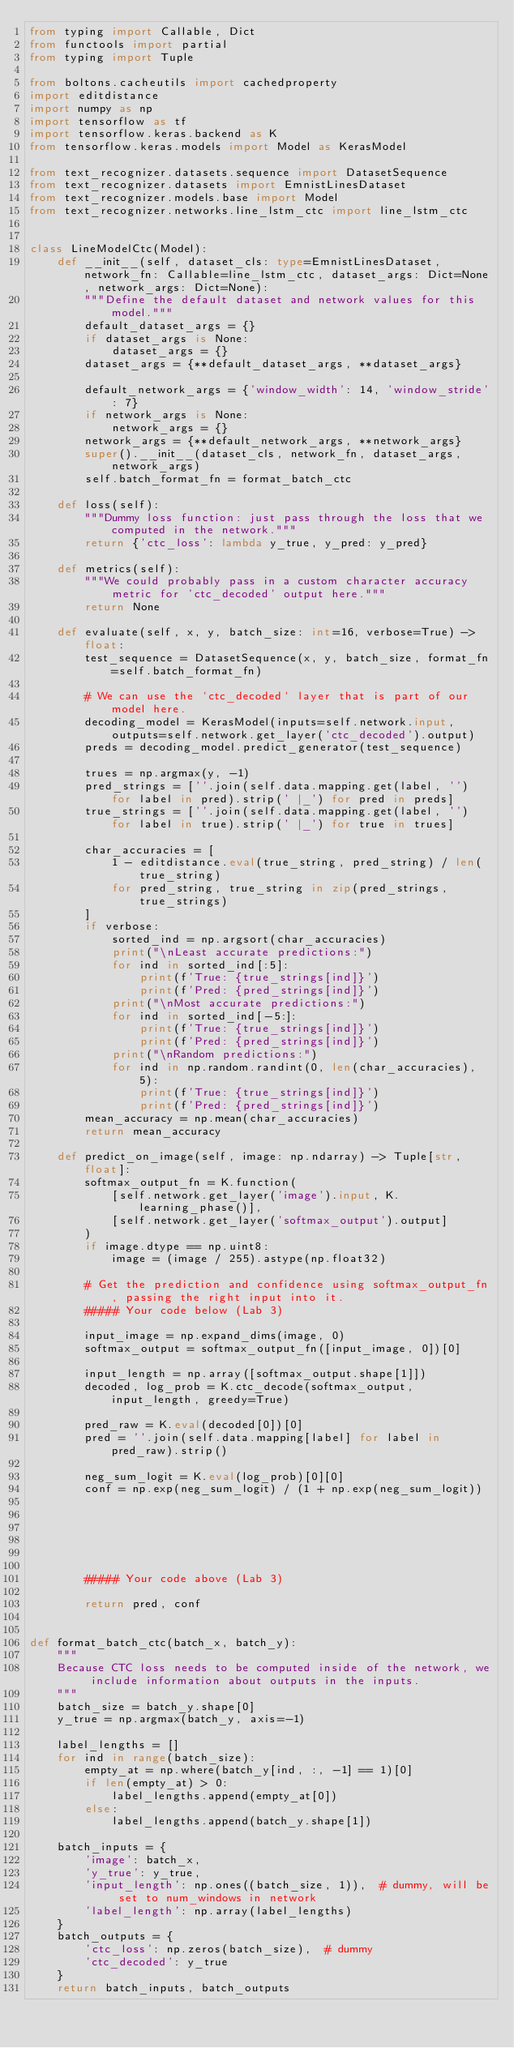<code> <loc_0><loc_0><loc_500><loc_500><_Python_>from typing import Callable, Dict
from functools import partial
from typing import Tuple

from boltons.cacheutils import cachedproperty
import editdistance
import numpy as np
import tensorflow as tf
import tensorflow.keras.backend as K
from tensorflow.keras.models import Model as KerasModel

from text_recognizer.datasets.sequence import DatasetSequence
from text_recognizer.datasets import EmnistLinesDataset
from text_recognizer.models.base import Model
from text_recognizer.networks.line_lstm_ctc import line_lstm_ctc


class LineModelCtc(Model):
    def __init__(self, dataset_cls: type=EmnistLinesDataset, network_fn: Callable=line_lstm_ctc, dataset_args: Dict=None, network_args: Dict=None):
        """Define the default dataset and network values for this model."""
        default_dataset_args = {}
        if dataset_args is None:
            dataset_args = {}
        dataset_args = {**default_dataset_args, **dataset_args}

        default_network_args = {'window_width': 14, 'window_stride': 7}
        if network_args is None:
            network_args = {}
        network_args = {**default_network_args, **network_args}
        super().__init__(dataset_cls, network_fn, dataset_args, network_args)
        self.batch_format_fn = format_batch_ctc

    def loss(self):
        """Dummy loss function: just pass through the loss that we computed in the network."""
        return {'ctc_loss': lambda y_true, y_pred: y_pred}

    def metrics(self):
        """We could probably pass in a custom character accuracy metric for 'ctc_decoded' output here."""
        return None

    def evaluate(self, x, y, batch_size: int=16, verbose=True) -> float:
        test_sequence = DatasetSequence(x, y, batch_size, format_fn=self.batch_format_fn)

        # We can use the `ctc_decoded` layer that is part of our model here.
        decoding_model = KerasModel(inputs=self.network.input, outputs=self.network.get_layer('ctc_decoded').output)
        preds = decoding_model.predict_generator(test_sequence)

        trues = np.argmax(y, -1)
        pred_strings = [''.join(self.data.mapping.get(label, '') for label in pred).strip(' |_') for pred in preds]
        true_strings = [''.join(self.data.mapping.get(label, '') for label in true).strip(' |_') for true in trues]

        char_accuracies = [
            1 - editdistance.eval(true_string, pred_string) / len(true_string)
            for pred_string, true_string in zip(pred_strings, true_strings)
        ]
        if verbose:
            sorted_ind = np.argsort(char_accuracies)
            print("\nLeast accurate predictions:")
            for ind in sorted_ind[:5]:
                print(f'True: {true_strings[ind]}')
                print(f'Pred: {pred_strings[ind]}')
            print("\nMost accurate predictions:")
            for ind in sorted_ind[-5:]:
                print(f'True: {true_strings[ind]}')
                print(f'Pred: {pred_strings[ind]}')
            print("\nRandom predictions:")
            for ind in np.random.randint(0, len(char_accuracies), 5):
                print(f'True: {true_strings[ind]}')
                print(f'Pred: {pred_strings[ind]}')
        mean_accuracy = np.mean(char_accuracies)
        return mean_accuracy

    def predict_on_image(self, image: np.ndarray) -> Tuple[str, float]:
        softmax_output_fn = K.function(
            [self.network.get_layer('image').input, K.learning_phase()],
            [self.network.get_layer('softmax_output').output]
        )
        if image.dtype == np.uint8:
            image = (image / 255).astype(np.float32)

        # Get the prediction and confidence using softmax_output_fn, passing the right input into it.
        ##### Your code below (Lab 3)

        input_image = np.expand_dims(image, 0)
        softmax_output = softmax_output_fn([input_image, 0])[0]

        input_length = np.array([softmax_output.shape[1]])
        decoded, log_prob = K.ctc_decode(softmax_output, input_length, greedy=True)

        pred_raw = K.eval(decoded[0])[0]
        pred = ''.join(self.data.mapping[label] for label in pred_raw).strip()

        neg_sum_logit = K.eval(log_prob)[0][0]
        conf = np.exp(neg_sum_logit) / (1 + np.exp(neg_sum_logit))






        ##### Your code above (Lab 3)

        return pred, conf


def format_batch_ctc(batch_x, batch_y):
    """
    Because CTC loss needs to be computed inside of the network, we include information about outputs in the inputs.
    """
    batch_size = batch_y.shape[0]
    y_true = np.argmax(batch_y, axis=-1)

    label_lengths = []
    for ind in range(batch_size):
        empty_at = np.where(batch_y[ind, :, -1] == 1)[0]
        if len(empty_at) > 0:
            label_lengths.append(empty_at[0])
        else:
            label_lengths.append(batch_y.shape[1])

    batch_inputs = {
        'image': batch_x,
        'y_true': y_true,
        'input_length': np.ones((batch_size, 1)),  # dummy, will be set to num_windows in network
        'label_length': np.array(label_lengths)
    }
    batch_outputs = {
        'ctc_loss': np.zeros(batch_size),  # dummy
        'ctc_decoded': y_true
    }
    return batch_inputs, batch_outputs

</code> 